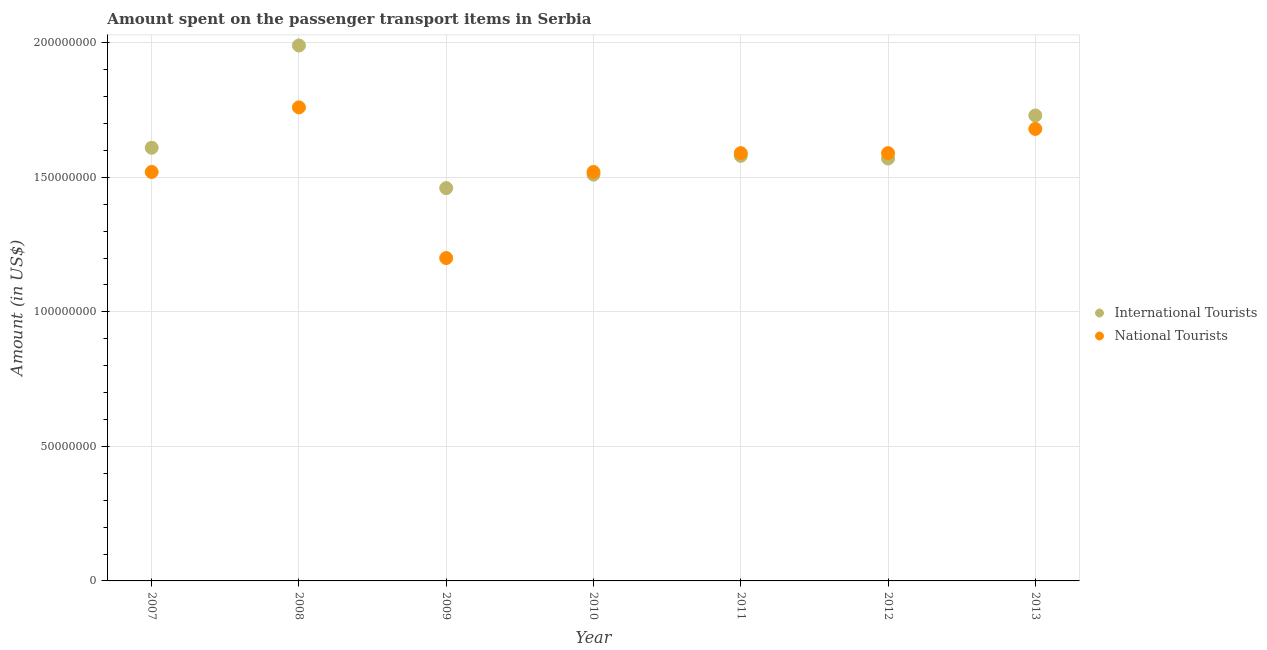How many different coloured dotlines are there?
Your response must be concise. 2. Is the number of dotlines equal to the number of legend labels?
Make the answer very short. Yes. What is the amount spent on transport items of international tourists in 2009?
Offer a very short reply. 1.46e+08. Across all years, what is the maximum amount spent on transport items of national tourists?
Ensure brevity in your answer.  1.76e+08. Across all years, what is the minimum amount spent on transport items of national tourists?
Offer a very short reply. 1.20e+08. What is the total amount spent on transport items of national tourists in the graph?
Your answer should be very brief. 1.09e+09. What is the difference between the amount spent on transport items of national tourists in 2007 and that in 2012?
Offer a terse response. -7.00e+06. What is the difference between the amount spent on transport items of international tourists in 2010 and the amount spent on transport items of national tourists in 2012?
Your response must be concise. -8.00e+06. What is the average amount spent on transport items of international tourists per year?
Provide a short and direct response. 1.64e+08. In the year 2009, what is the difference between the amount spent on transport items of national tourists and amount spent on transport items of international tourists?
Your answer should be very brief. -2.60e+07. In how many years, is the amount spent on transport items of international tourists greater than 110000000 US$?
Make the answer very short. 7. What is the ratio of the amount spent on transport items of international tourists in 2008 to that in 2010?
Your answer should be compact. 1.32. Is the amount spent on transport items of national tourists in 2007 less than that in 2008?
Your answer should be very brief. Yes. What is the difference between the highest and the lowest amount spent on transport items of international tourists?
Make the answer very short. 5.30e+07. Does the amount spent on transport items of national tourists monotonically increase over the years?
Your answer should be compact. No. How many dotlines are there?
Ensure brevity in your answer.  2. What is the difference between two consecutive major ticks on the Y-axis?
Your response must be concise. 5.00e+07. Does the graph contain any zero values?
Your answer should be compact. No. Does the graph contain grids?
Provide a succinct answer. Yes. Where does the legend appear in the graph?
Your response must be concise. Center right. What is the title of the graph?
Ensure brevity in your answer.  Amount spent on the passenger transport items in Serbia. What is the label or title of the Y-axis?
Provide a succinct answer. Amount (in US$). What is the Amount (in US$) in International Tourists in 2007?
Keep it short and to the point. 1.61e+08. What is the Amount (in US$) of National Tourists in 2007?
Offer a very short reply. 1.52e+08. What is the Amount (in US$) of International Tourists in 2008?
Your answer should be very brief. 1.99e+08. What is the Amount (in US$) of National Tourists in 2008?
Offer a terse response. 1.76e+08. What is the Amount (in US$) of International Tourists in 2009?
Offer a very short reply. 1.46e+08. What is the Amount (in US$) in National Tourists in 2009?
Your answer should be compact. 1.20e+08. What is the Amount (in US$) in International Tourists in 2010?
Your response must be concise. 1.51e+08. What is the Amount (in US$) in National Tourists in 2010?
Give a very brief answer. 1.52e+08. What is the Amount (in US$) of International Tourists in 2011?
Give a very brief answer. 1.58e+08. What is the Amount (in US$) of National Tourists in 2011?
Keep it short and to the point. 1.59e+08. What is the Amount (in US$) of International Tourists in 2012?
Provide a short and direct response. 1.57e+08. What is the Amount (in US$) in National Tourists in 2012?
Provide a short and direct response. 1.59e+08. What is the Amount (in US$) of International Tourists in 2013?
Keep it short and to the point. 1.73e+08. What is the Amount (in US$) in National Tourists in 2013?
Your answer should be very brief. 1.68e+08. Across all years, what is the maximum Amount (in US$) of International Tourists?
Your answer should be very brief. 1.99e+08. Across all years, what is the maximum Amount (in US$) in National Tourists?
Provide a succinct answer. 1.76e+08. Across all years, what is the minimum Amount (in US$) in International Tourists?
Offer a very short reply. 1.46e+08. Across all years, what is the minimum Amount (in US$) in National Tourists?
Provide a short and direct response. 1.20e+08. What is the total Amount (in US$) in International Tourists in the graph?
Your answer should be very brief. 1.14e+09. What is the total Amount (in US$) of National Tourists in the graph?
Ensure brevity in your answer.  1.09e+09. What is the difference between the Amount (in US$) in International Tourists in 2007 and that in 2008?
Offer a very short reply. -3.80e+07. What is the difference between the Amount (in US$) in National Tourists in 2007 and that in 2008?
Offer a very short reply. -2.40e+07. What is the difference between the Amount (in US$) in International Tourists in 2007 and that in 2009?
Your answer should be very brief. 1.50e+07. What is the difference between the Amount (in US$) of National Tourists in 2007 and that in 2009?
Provide a succinct answer. 3.20e+07. What is the difference between the Amount (in US$) in International Tourists in 2007 and that in 2010?
Your response must be concise. 1.00e+07. What is the difference between the Amount (in US$) in National Tourists in 2007 and that in 2010?
Make the answer very short. 0. What is the difference between the Amount (in US$) in International Tourists in 2007 and that in 2011?
Provide a short and direct response. 3.00e+06. What is the difference between the Amount (in US$) of National Tourists in 2007 and that in 2011?
Ensure brevity in your answer.  -7.00e+06. What is the difference between the Amount (in US$) of National Tourists in 2007 and that in 2012?
Your answer should be compact. -7.00e+06. What is the difference between the Amount (in US$) of International Tourists in 2007 and that in 2013?
Your answer should be very brief. -1.20e+07. What is the difference between the Amount (in US$) in National Tourists in 2007 and that in 2013?
Give a very brief answer. -1.60e+07. What is the difference between the Amount (in US$) in International Tourists in 2008 and that in 2009?
Offer a terse response. 5.30e+07. What is the difference between the Amount (in US$) in National Tourists in 2008 and that in 2009?
Your answer should be very brief. 5.60e+07. What is the difference between the Amount (in US$) of International Tourists in 2008 and that in 2010?
Keep it short and to the point. 4.80e+07. What is the difference between the Amount (in US$) of National Tourists in 2008 and that in 2010?
Offer a terse response. 2.40e+07. What is the difference between the Amount (in US$) of International Tourists in 2008 and that in 2011?
Your answer should be very brief. 4.10e+07. What is the difference between the Amount (in US$) in National Tourists in 2008 and that in 2011?
Your response must be concise. 1.70e+07. What is the difference between the Amount (in US$) of International Tourists in 2008 and that in 2012?
Your response must be concise. 4.20e+07. What is the difference between the Amount (in US$) of National Tourists in 2008 and that in 2012?
Offer a very short reply. 1.70e+07. What is the difference between the Amount (in US$) in International Tourists in 2008 and that in 2013?
Provide a short and direct response. 2.60e+07. What is the difference between the Amount (in US$) of National Tourists in 2008 and that in 2013?
Provide a short and direct response. 8.00e+06. What is the difference between the Amount (in US$) in International Tourists in 2009 and that in 2010?
Your response must be concise. -5.00e+06. What is the difference between the Amount (in US$) of National Tourists in 2009 and that in 2010?
Give a very brief answer. -3.20e+07. What is the difference between the Amount (in US$) of International Tourists in 2009 and that in 2011?
Provide a succinct answer. -1.20e+07. What is the difference between the Amount (in US$) in National Tourists in 2009 and that in 2011?
Offer a terse response. -3.90e+07. What is the difference between the Amount (in US$) of International Tourists in 2009 and that in 2012?
Provide a succinct answer. -1.10e+07. What is the difference between the Amount (in US$) in National Tourists in 2009 and that in 2012?
Your answer should be compact. -3.90e+07. What is the difference between the Amount (in US$) of International Tourists in 2009 and that in 2013?
Ensure brevity in your answer.  -2.70e+07. What is the difference between the Amount (in US$) of National Tourists in 2009 and that in 2013?
Provide a succinct answer. -4.80e+07. What is the difference between the Amount (in US$) in International Tourists in 2010 and that in 2011?
Offer a very short reply. -7.00e+06. What is the difference between the Amount (in US$) of National Tourists in 2010 and that in 2011?
Provide a short and direct response. -7.00e+06. What is the difference between the Amount (in US$) in International Tourists in 2010 and that in 2012?
Your response must be concise. -6.00e+06. What is the difference between the Amount (in US$) in National Tourists in 2010 and that in 2012?
Give a very brief answer. -7.00e+06. What is the difference between the Amount (in US$) of International Tourists in 2010 and that in 2013?
Provide a short and direct response. -2.20e+07. What is the difference between the Amount (in US$) in National Tourists in 2010 and that in 2013?
Your response must be concise. -1.60e+07. What is the difference between the Amount (in US$) of International Tourists in 2011 and that in 2013?
Your answer should be very brief. -1.50e+07. What is the difference between the Amount (in US$) in National Tourists in 2011 and that in 2013?
Your response must be concise. -9.00e+06. What is the difference between the Amount (in US$) of International Tourists in 2012 and that in 2013?
Your answer should be very brief. -1.60e+07. What is the difference between the Amount (in US$) in National Tourists in 2012 and that in 2013?
Provide a succinct answer. -9.00e+06. What is the difference between the Amount (in US$) in International Tourists in 2007 and the Amount (in US$) in National Tourists in 2008?
Keep it short and to the point. -1.50e+07. What is the difference between the Amount (in US$) of International Tourists in 2007 and the Amount (in US$) of National Tourists in 2009?
Offer a very short reply. 4.10e+07. What is the difference between the Amount (in US$) of International Tourists in 2007 and the Amount (in US$) of National Tourists in 2010?
Make the answer very short. 9.00e+06. What is the difference between the Amount (in US$) of International Tourists in 2007 and the Amount (in US$) of National Tourists in 2012?
Your response must be concise. 2.00e+06. What is the difference between the Amount (in US$) of International Tourists in 2007 and the Amount (in US$) of National Tourists in 2013?
Your answer should be compact. -7.00e+06. What is the difference between the Amount (in US$) of International Tourists in 2008 and the Amount (in US$) of National Tourists in 2009?
Your answer should be very brief. 7.90e+07. What is the difference between the Amount (in US$) in International Tourists in 2008 and the Amount (in US$) in National Tourists in 2010?
Your response must be concise. 4.70e+07. What is the difference between the Amount (in US$) in International Tourists in 2008 and the Amount (in US$) in National Tourists in 2011?
Keep it short and to the point. 4.00e+07. What is the difference between the Amount (in US$) of International Tourists in 2008 and the Amount (in US$) of National Tourists in 2012?
Your response must be concise. 4.00e+07. What is the difference between the Amount (in US$) of International Tourists in 2008 and the Amount (in US$) of National Tourists in 2013?
Keep it short and to the point. 3.10e+07. What is the difference between the Amount (in US$) of International Tourists in 2009 and the Amount (in US$) of National Tourists in 2010?
Ensure brevity in your answer.  -6.00e+06. What is the difference between the Amount (in US$) in International Tourists in 2009 and the Amount (in US$) in National Tourists in 2011?
Make the answer very short. -1.30e+07. What is the difference between the Amount (in US$) of International Tourists in 2009 and the Amount (in US$) of National Tourists in 2012?
Offer a very short reply. -1.30e+07. What is the difference between the Amount (in US$) in International Tourists in 2009 and the Amount (in US$) in National Tourists in 2013?
Your answer should be compact. -2.20e+07. What is the difference between the Amount (in US$) in International Tourists in 2010 and the Amount (in US$) in National Tourists in 2011?
Ensure brevity in your answer.  -8.00e+06. What is the difference between the Amount (in US$) of International Tourists in 2010 and the Amount (in US$) of National Tourists in 2012?
Your response must be concise. -8.00e+06. What is the difference between the Amount (in US$) in International Tourists in 2010 and the Amount (in US$) in National Tourists in 2013?
Your answer should be compact. -1.70e+07. What is the difference between the Amount (in US$) of International Tourists in 2011 and the Amount (in US$) of National Tourists in 2012?
Offer a very short reply. -1.00e+06. What is the difference between the Amount (in US$) in International Tourists in 2011 and the Amount (in US$) in National Tourists in 2013?
Offer a terse response. -1.00e+07. What is the difference between the Amount (in US$) of International Tourists in 2012 and the Amount (in US$) of National Tourists in 2013?
Make the answer very short. -1.10e+07. What is the average Amount (in US$) of International Tourists per year?
Provide a short and direct response. 1.64e+08. What is the average Amount (in US$) in National Tourists per year?
Ensure brevity in your answer.  1.55e+08. In the year 2007, what is the difference between the Amount (in US$) of International Tourists and Amount (in US$) of National Tourists?
Provide a succinct answer. 9.00e+06. In the year 2008, what is the difference between the Amount (in US$) in International Tourists and Amount (in US$) in National Tourists?
Offer a terse response. 2.30e+07. In the year 2009, what is the difference between the Amount (in US$) in International Tourists and Amount (in US$) in National Tourists?
Provide a short and direct response. 2.60e+07. In the year 2010, what is the difference between the Amount (in US$) in International Tourists and Amount (in US$) in National Tourists?
Your answer should be very brief. -1.00e+06. In the year 2012, what is the difference between the Amount (in US$) of International Tourists and Amount (in US$) of National Tourists?
Offer a terse response. -2.00e+06. In the year 2013, what is the difference between the Amount (in US$) in International Tourists and Amount (in US$) in National Tourists?
Ensure brevity in your answer.  5.00e+06. What is the ratio of the Amount (in US$) in International Tourists in 2007 to that in 2008?
Provide a succinct answer. 0.81. What is the ratio of the Amount (in US$) of National Tourists in 2007 to that in 2008?
Offer a terse response. 0.86. What is the ratio of the Amount (in US$) of International Tourists in 2007 to that in 2009?
Your response must be concise. 1.1. What is the ratio of the Amount (in US$) of National Tourists in 2007 to that in 2009?
Make the answer very short. 1.27. What is the ratio of the Amount (in US$) of International Tourists in 2007 to that in 2010?
Ensure brevity in your answer.  1.07. What is the ratio of the Amount (in US$) in National Tourists in 2007 to that in 2011?
Provide a succinct answer. 0.96. What is the ratio of the Amount (in US$) of International Tourists in 2007 to that in 2012?
Offer a terse response. 1.03. What is the ratio of the Amount (in US$) of National Tourists in 2007 to that in 2012?
Provide a short and direct response. 0.96. What is the ratio of the Amount (in US$) in International Tourists in 2007 to that in 2013?
Your answer should be very brief. 0.93. What is the ratio of the Amount (in US$) in National Tourists in 2007 to that in 2013?
Offer a terse response. 0.9. What is the ratio of the Amount (in US$) in International Tourists in 2008 to that in 2009?
Provide a succinct answer. 1.36. What is the ratio of the Amount (in US$) of National Tourists in 2008 to that in 2009?
Your response must be concise. 1.47. What is the ratio of the Amount (in US$) in International Tourists in 2008 to that in 2010?
Give a very brief answer. 1.32. What is the ratio of the Amount (in US$) of National Tourists in 2008 to that in 2010?
Your response must be concise. 1.16. What is the ratio of the Amount (in US$) in International Tourists in 2008 to that in 2011?
Offer a terse response. 1.26. What is the ratio of the Amount (in US$) in National Tourists in 2008 to that in 2011?
Keep it short and to the point. 1.11. What is the ratio of the Amount (in US$) in International Tourists in 2008 to that in 2012?
Your answer should be very brief. 1.27. What is the ratio of the Amount (in US$) of National Tourists in 2008 to that in 2012?
Give a very brief answer. 1.11. What is the ratio of the Amount (in US$) in International Tourists in 2008 to that in 2013?
Your answer should be very brief. 1.15. What is the ratio of the Amount (in US$) of National Tourists in 2008 to that in 2013?
Provide a succinct answer. 1.05. What is the ratio of the Amount (in US$) of International Tourists in 2009 to that in 2010?
Your response must be concise. 0.97. What is the ratio of the Amount (in US$) in National Tourists in 2009 to that in 2010?
Offer a very short reply. 0.79. What is the ratio of the Amount (in US$) of International Tourists in 2009 to that in 2011?
Ensure brevity in your answer.  0.92. What is the ratio of the Amount (in US$) of National Tourists in 2009 to that in 2011?
Your answer should be very brief. 0.75. What is the ratio of the Amount (in US$) in International Tourists in 2009 to that in 2012?
Make the answer very short. 0.93. What is the ratio of the Amount (in US$) in National Tourists in 2009 to that in 2012?
Your answer should be very brief. 0.75. What is the ratio of the Amount (in US$) in International Tourists in 2009 to that in 2013?
Make the answer very short. 0.84. What is the ratio of the Amount (in US$) of National Tourists in 2009 to that in 2013?
Your answer should be compact. 0.71. What is the ratio of the Amount (in US$) of International Tourists in 2010 to that in 2011?
Your response must be concise. 0.96. What is the ratio of the Amount (in US$) in National Tourists in 2010 to that in 2011?
Your response must be concise. 0.96. What is the ratio of the Amount (in US$) in International Tourists in 2010 to that in 2012?
Ensure brevity in your answer.  0.96. What is the ratio of the Amount (in US$) in National Tourists in 2010 to that in 2012?
Keep it short and to the point. 0.96. What is the ratio of the Amount (in US$) in International Tourists in 2010 to that in 2013?
Give a very brief answer. 0.87. What is the ratio of the Amount (in US$) of National Tourists in 2010 to that in 2013?
Provide a short and direct response. 0.9. What is the ratio of the Amount (in US$) of International Tourists in 2011 to that in 2012?
Provide a short and direct response. 1.01. What is the ratio of the Amount (in US$) in National Tourists in 2011 to that in 2012?
Keep it short and to the point. 1. What is the ratio of the Amount (in US$) in International Tourists in 2011 to that in 2013?
Keep it short and to the point. 0.91. What is the ratio of the Amount (in US$) of National Tourists in 2011 to that in 2013?
Give a very brief answer. 0.95. What is the ratio of the Amount (in US$) of International Tourists in 2012 to that in 2013?
Provide a short and direct response. 0.91. What is the ratio of the Amount (in US$) in National Tourists in 2012 to that in 2013?
Provide a short and direct response. 0.95. What is the difference between the highest and the second highest Amount (in US$) in International Tourists?
Give a very brief answer. 2.60e+07. What is the difference between the highest and the lowest Amount (in US$) of International Tourists?
Ensure brevity in your answer.  5.30e+07. What is the difference between the highest and the lowest Amount (in US$) of National Tourists?
Provide a short and direct response. 5.60e+07. 